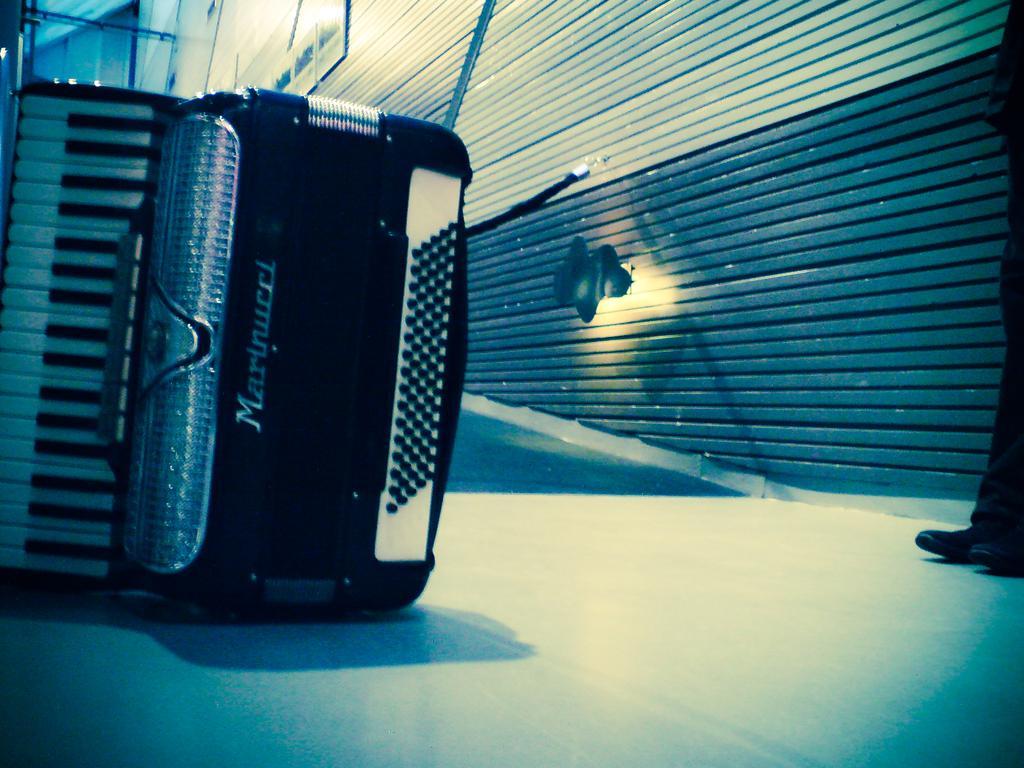How would you summarize this image in a sentence or two? In this image I can see musical instrument on the floor. Here I can see a person's leg. Here I can see a wall and light on the wall. 